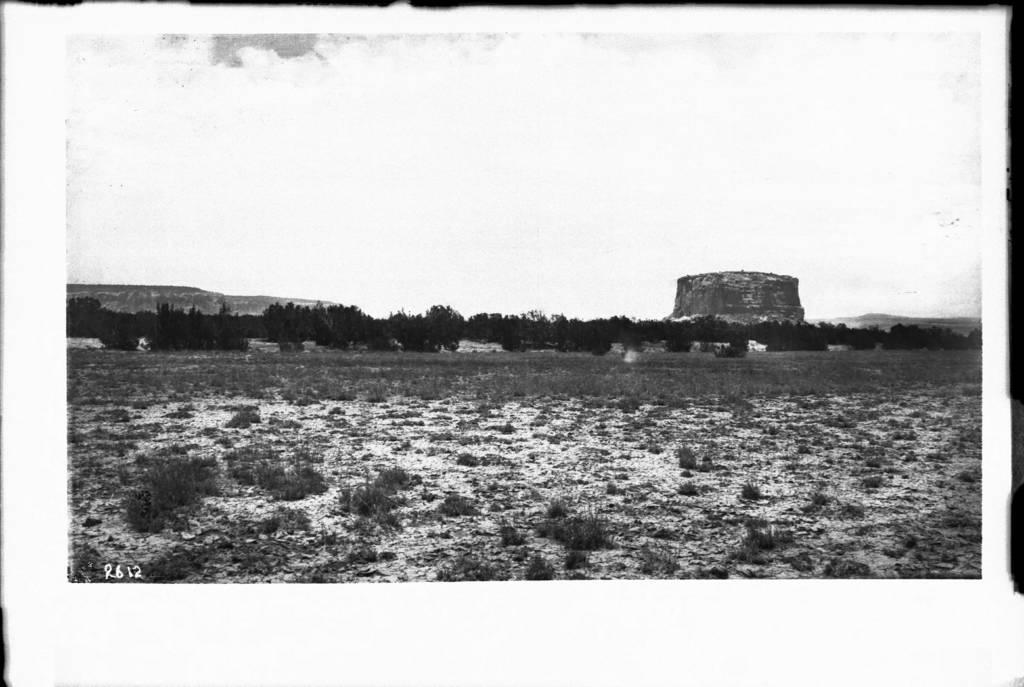What is the color scheme of the image? The image is black and white. What type of terrain can be seen in the image? There is a land with grass in the image. What natural features are visible in the background of the image? Mountains, trees, and the sky are visible in the background of the image. What type of list is being used to measure the degree of dirt in the image? There is no list or measurement of dirt in the image, as it is a black and white landscape featuring grass, mountains, trees, and the sky. 